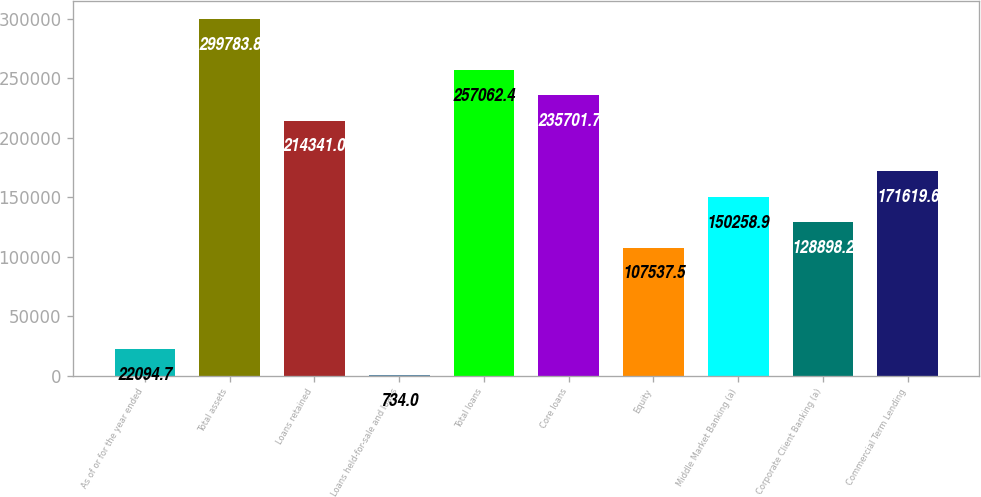Convert chart. <chart><loc_0><loc_0><loc_500><loc_500><bar_chart><fcel>As of or for the year ended<fcel>Total assets<fcel>Loans retained<fcel>Loans held-for-sale and loans<fcel>Total loans<fcel>Core loans<fcel>Equity<fcel>Middle Market Banking (a)<fcel>Corporate Client Banking (a)<fcel>Commercial Term Lending<nl><fcel>22094.7<fcel>299784<fcel>214341<fcel>734<fcel>257062<fcel>235702<fcel>107538<fcel>150259<fcel>128898<fcel>171620<nl></chart> 